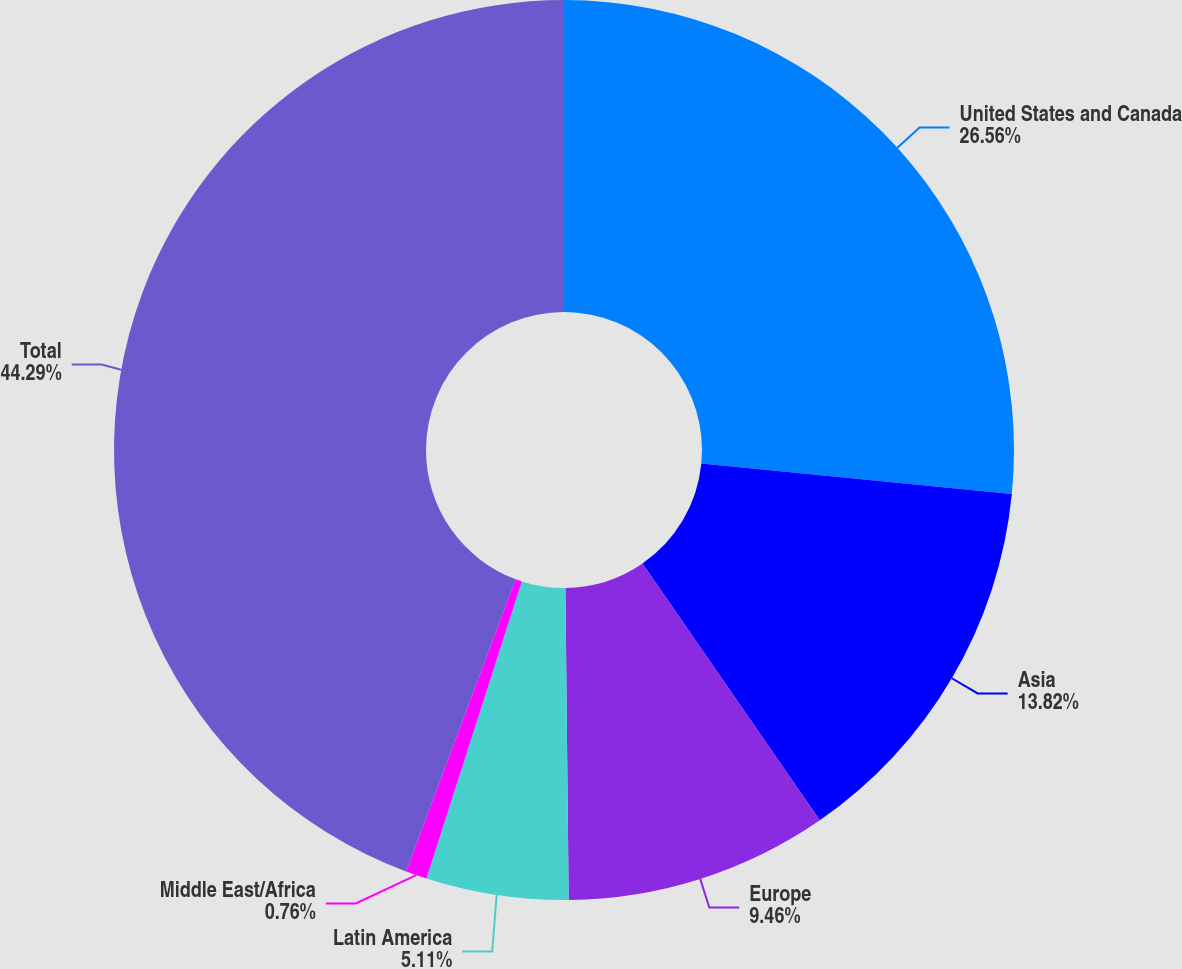Convert chart. <chart><loc_0><loc_0><loc_500><loc_500><pie_chart><fcel>United States and Canada<fcel>Asia<fcel>Europe<fcel>Latin America<fcel>Middle East/Africa<fcel>Total<nl><fcel>26.56%<fcel>13.82%<fcel>9.46%<fcel>5.11%<fcel>0.76%<fcel>44.3%<nl></chart> 